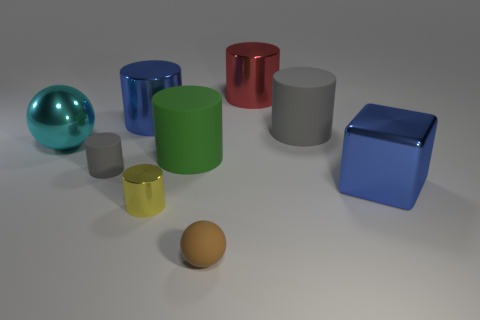Subtract all gray cylinders. How many cylinders are left? 4 Subtract all big blue cylinders. How many cylinders are left? 5 Subtract 4 cylinders. How many cylinders are left? 2 Subtract all purple cylinders. Subtract all gray balls. How many cylinders are left? 6 Subtract all spheres. How many objects are left? 7 Subtract 0 green balls. How many objects are left? 9 Subtract all blue blocks. Subtract all small objects. How many objects are left? 5 Add 8 cyan shiny things. How many cyan shiny things are left? 9 Add 5 large metal spheres. How many large metal spheres exist? 6 